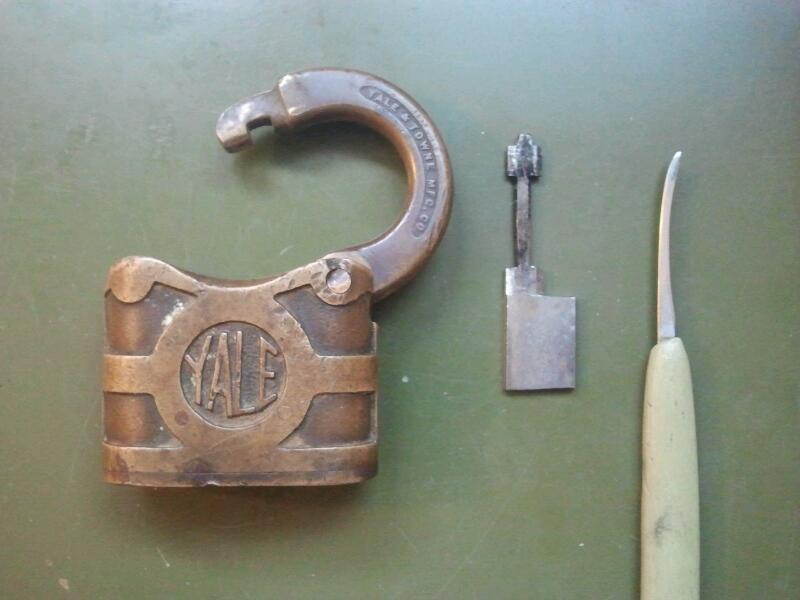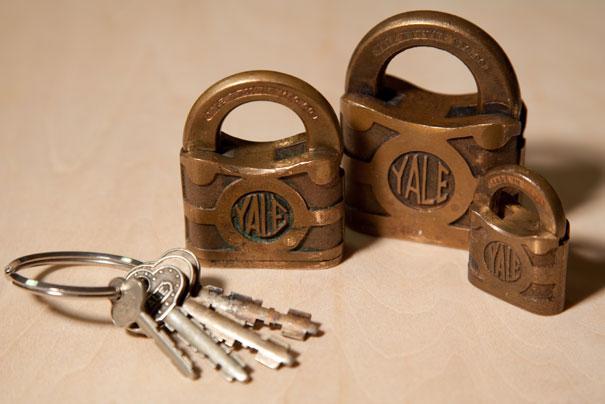The first image is the image on the left, the second image is the image on the right. For the images displayed, is the sentence "There are four closed and locked padlocks in total." factually correct? Answer yes or no. No. The first image is the image on the left, the second image is the image on the right. Examine the images to the left and right. Is the description "An image shows three locks of similar style and includes some keys." accurate? Answer yes or no. Yes. 